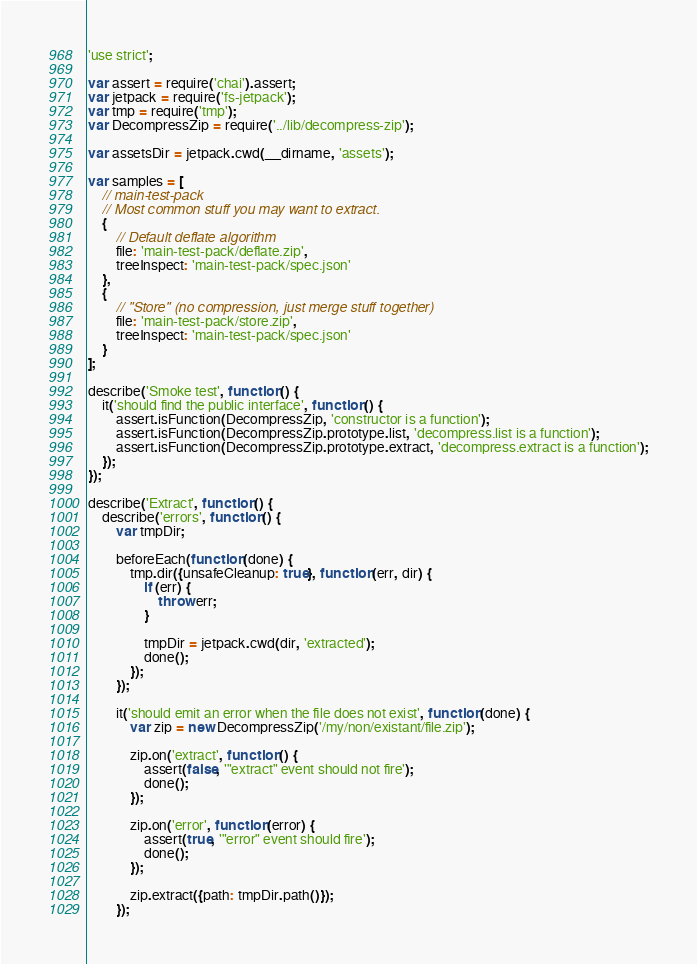<code> <loc_0><loc_0><loc_500><loc_500><_JavaScript_>'use strict';

var assert = require('chai').assert;
var jetpack = require('fs-jetpack');
var tmp = require('tmp');
var DecompressZip = require('../lib/decompress-zip');

var assetsDir = jetpack.cwd(__dirname, 'assets');

var samples = [
    // main-test-pack
    // Most common stuff you may want to extract.
    {
        // Default deflate algorithm
        file: 'main-test-pack/deflate.zip',
        treeInspect: 'main-test-pack/spec.json'
    },
    {
        // "Store" (no compression, just merge stuff together)
        file: 'main-test-pack/store.zip',
        treeInspect: 'main-test-pack/spec.json'
    }
];

describe('Smoke test', function () {
    it('should find the public interface', function () {
        assert.isFunction(DecompressZip, 'constructor is a function');
        assert.isFunction(DecompressZip.prototype.list, 'decompress.list is a function');
        assert.isFunction(DecompressZip.prototype.extract, 'decompress.extract is a function');
    });
});

describe('Extract', function () {
    describe('errors', function () {
        var tmpDir;

        beforeEach(function (done) {
            tmp.dir({unsafeCleanup: true}, function (err, dir) {
                if (err) {
                    throw err;
                }

                tmpDir = jetpack.cwd(dir, 'extracted');
                done();
            });
        });

        it('should emit an error when the file does not exist', function (done) {
            var zip = new DecompressZip('/my/non/existant/file.zip');

            zip.on('extract', function () {
                assert(false, '"extract" event should not fire');
                done();
            });

            zip.on('error', function (error) {
                assert(true, '"error" event should fire');
                done();
            });

            zip.extract({path: tmpDir.path()});
        });
</code> 